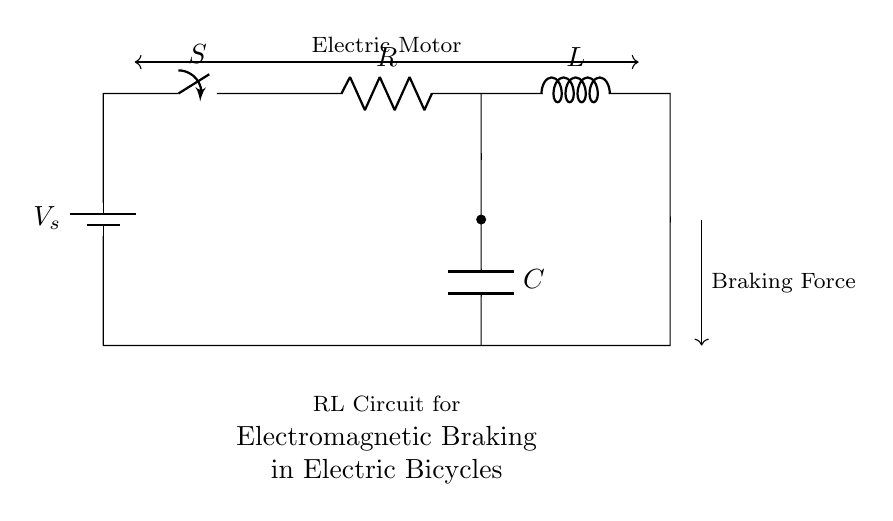What is the symbol for the power source? The power source is represented by a battery symbol, which is shown at the top of the circuit diagram.
Answer: Battery What component is responsible for resistance in the circuit? The resistor is the component that provides resistance, indicated by the label "R" in the diagram.
Answer: Resistor What type of circuit is represented? The circuit is specifically an RL circuit, which consists of a resistor and an inductor connected in series and is labeled as such in the diagram.
Answer: RL Circuit What does the switch control in this circuit? The switch (labeled "S") controls the flow of current by opening or closing the circuit, allowing or stopping the current from flowing through the components.
Answer: Current flow How does the inductor affect the braking force? The inductor (labeled "L") generates a magnetic field that opposes changes in current, which helps create braking force when the electric motor is turned off or switched to braking mode.
Answer: Magnetic field What role does the capacitor play in this circuit? The capacitor (labeled "C") stores and releases electrical energy, which helps smooth out fluctuations in the current and supports braking action by providing additional energy.
Answer: Energy storage What is the purpose of connecting the components in this configuration? The specific configuration allows for electromagnetic braking by controlling energy dissipation through the resistor and the inductor while utilizing the capacitor for additional support, facilitating controlled braking.
Answer: Electromagnetic braking 